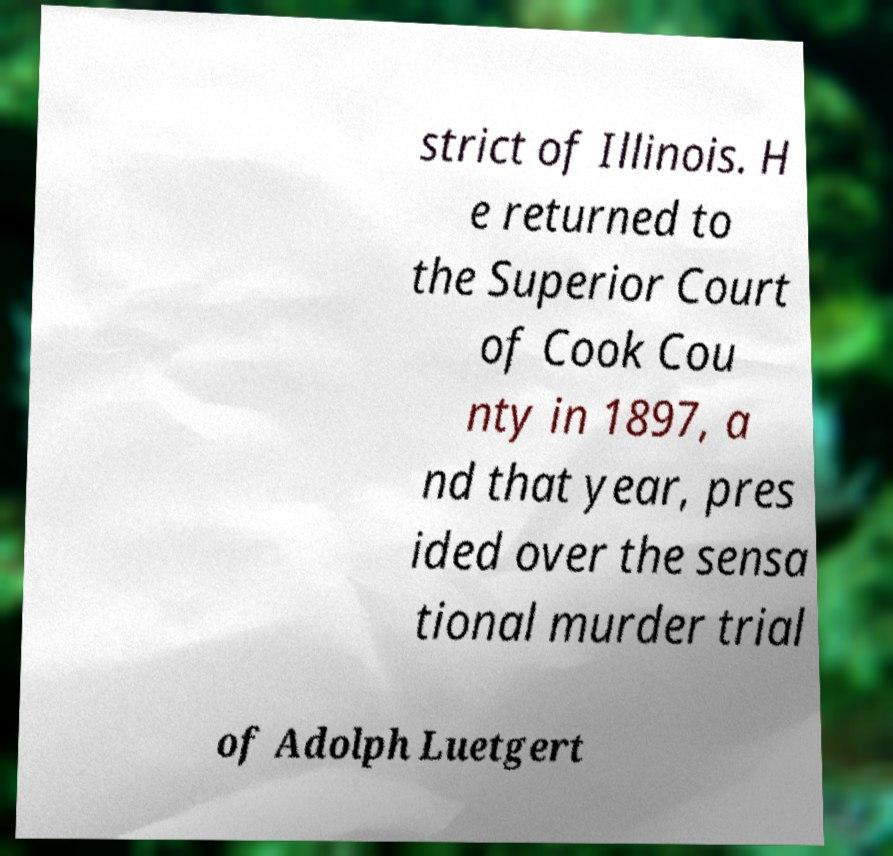Please read and relay the text visible in this image. What does it say? strict of Illinois. H e returned to the Superior Court of Cook Cou nty in 1897, a nd that year, pres ided over the sensa tional murder trial of Adolph Luetgert 